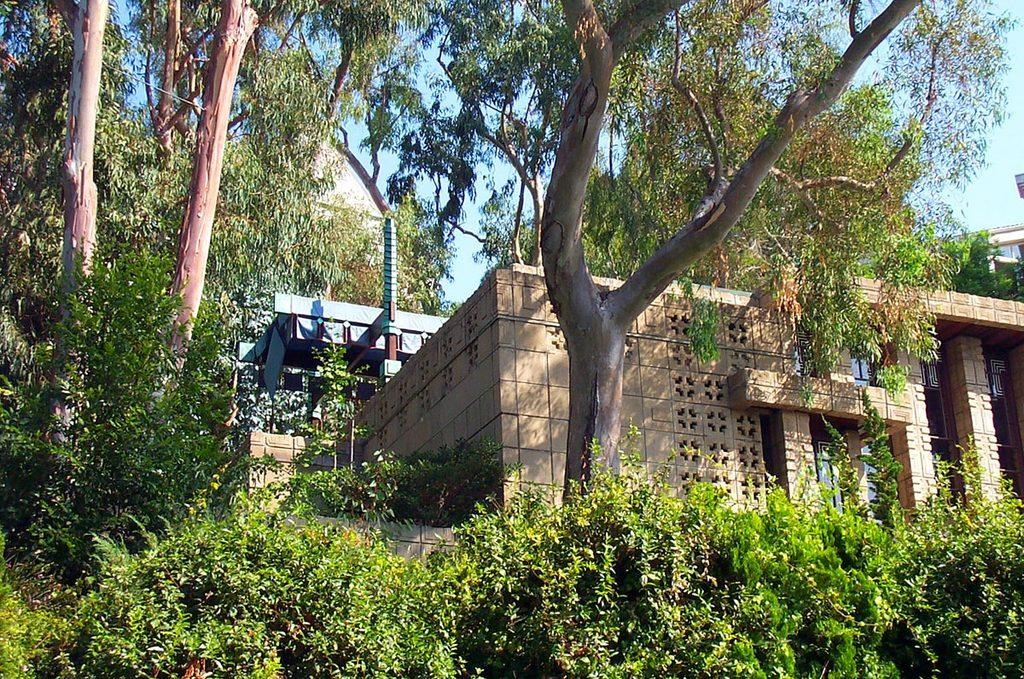What type of vegetation can be seen in the image? There are trees in the image. What type of structures are present in the image? There are buildings in the image. What part of the natural environment is visible in the image? The sky is visible in the background of the image. What type of scent can be detected in the image? There is no indication of a scent in the image, as it is a visual representation. What is the income of the people living in the buildings in the image? There is no information about the income of the people living in the buildings in the image. 